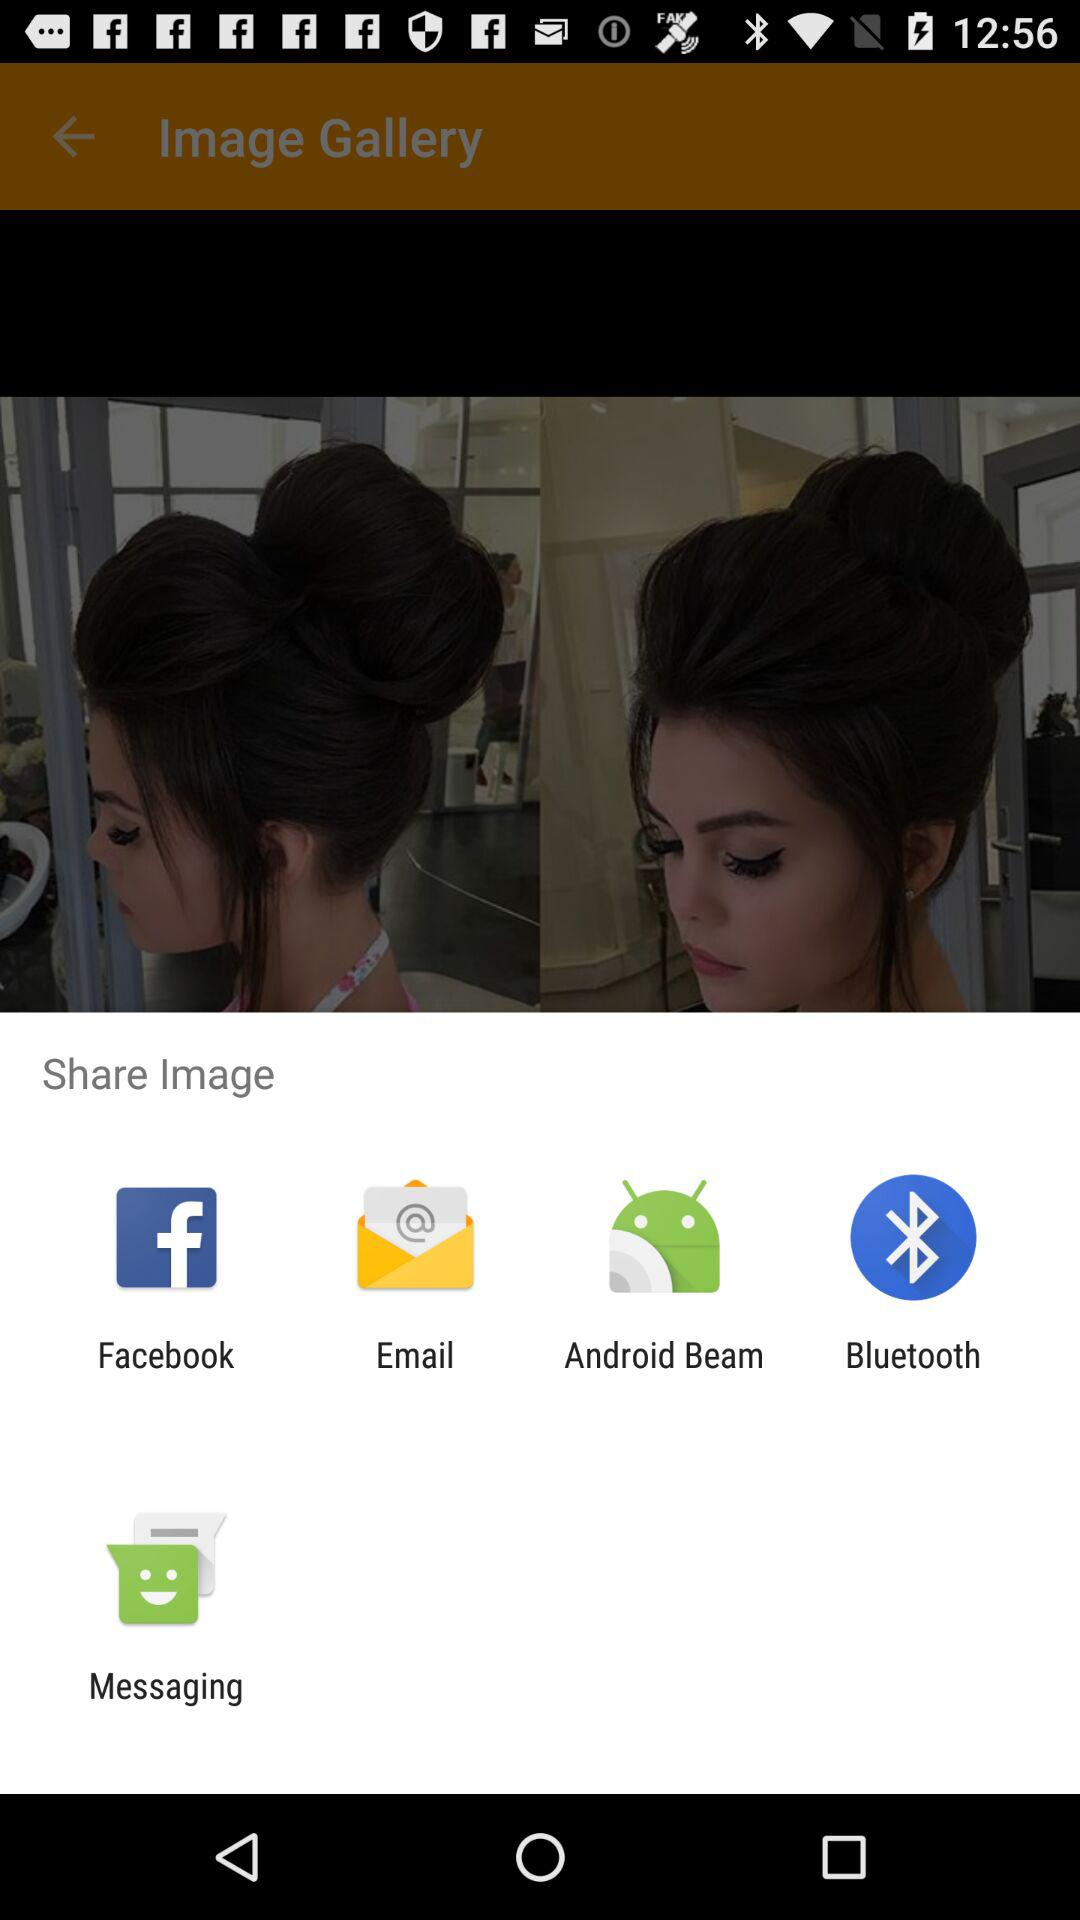Through which applications can we share? You can share through "Facebook", "Email", "Android Beam", "Bluetooth" and "Messaging" applications. 